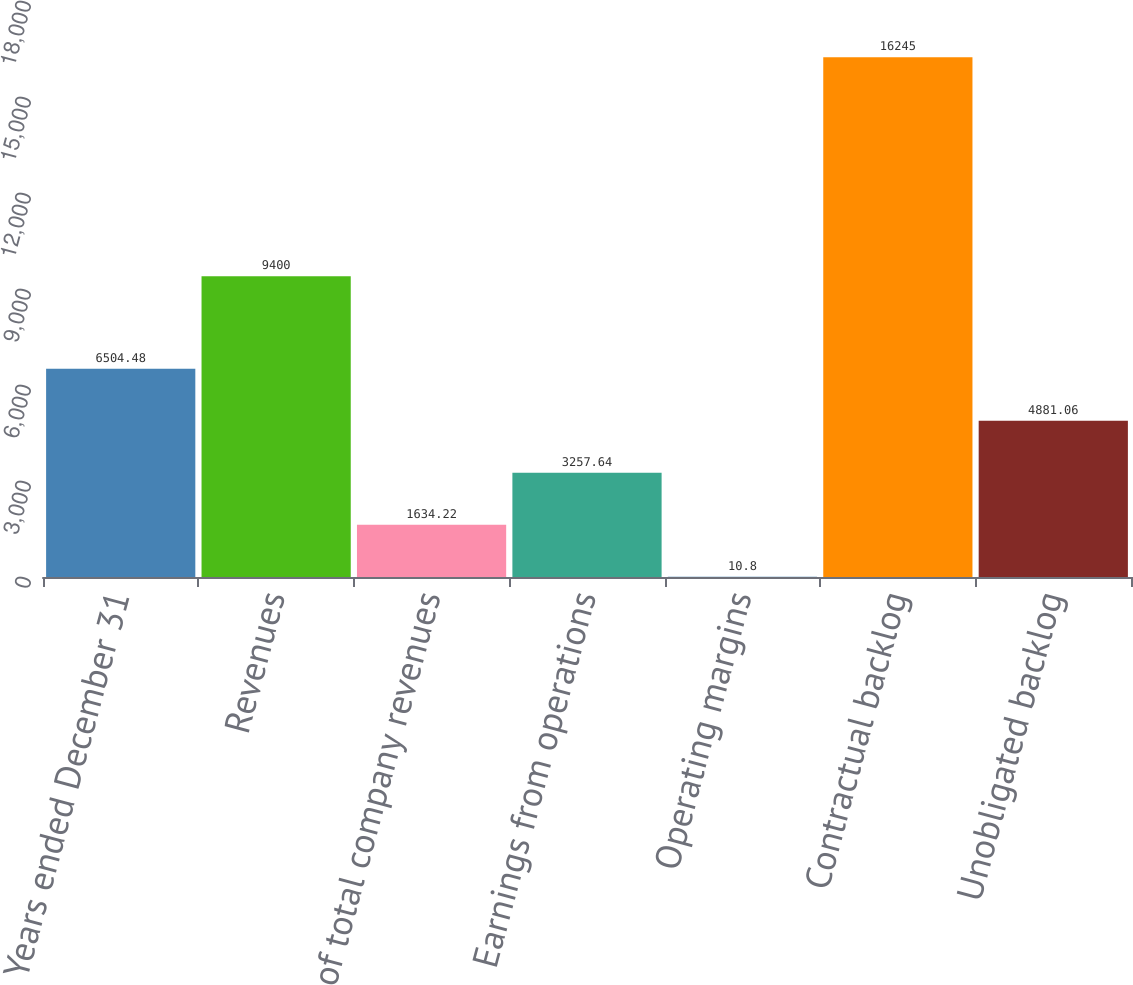Convert chart. <chart><loc_0><loc_0><loc_500><loc_500><bar_chart><fcel>Years ended December 31<fcel>Revenues<fcel>of total company revenues<fcel>Earnings from operations<fcel>Operating margins<fcel>Contractual backlog<fcel>Unobligated backlog<nl><fcel>6504.48<fcel>9400<fcel>1634.22<fcel>3257.64<fcel>10.8<fcel>16245<fcel>4881.06<nl></chart> 